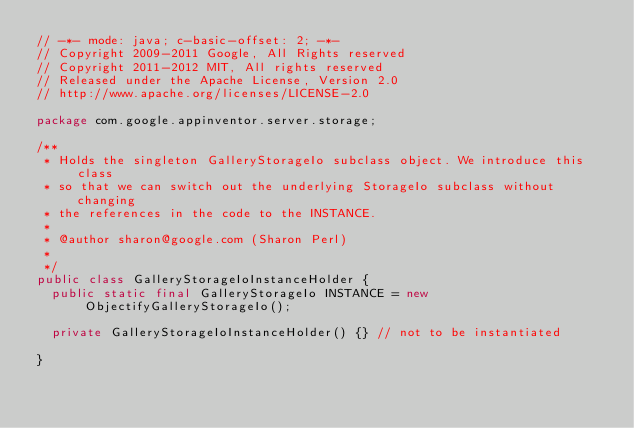<code> <loc_0><loc_0><loc_500><loc_500><_Java_>// -*- mode: java; c-basic-offset: 2; -*-
// Copyright 2009-2011 Google, All Rights reserved
// Copyright 2011-2012 MIT, All rights reserved
// Released under the Apache License, Version 2.0
// http://www.apache.org/licenses/LICENSE-2.0

package com.google.appinventor.server.storage;

/**
 * Holds the singleton GalleryStorageIo subclass object. We introduce this class
 * so that we can switch out the underlying StorageIo subclass without changing
 * the references in the code to the INSTANCE.
 *
 * @author sharon@google.com (Sharon Perl)
 *
 */
public class GalleryStorageIoInstanceHolder {
  public static final GalleryStorageIo INSTANCE = new ObjectifyGalleryStorageIo();

  private GalleryStorageIoInstanceHolder() {} // not to be instantiated

}
</code> 